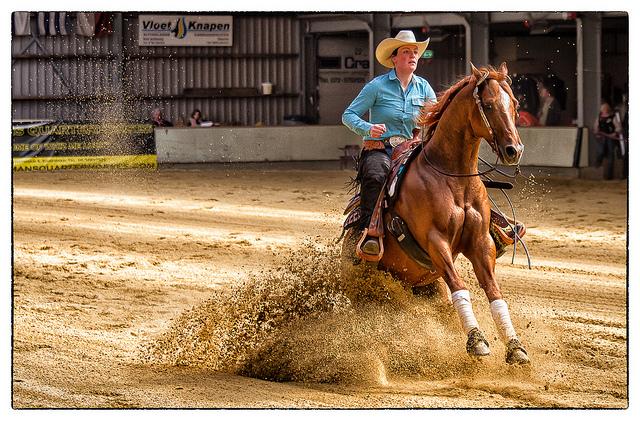Will the man hurt himself?
Quick response, please. No. Is the woman wearing a hat?
Concise answer only. Yes. What is the woman sitting on?
Short answer required. Horse. Is the horse hurt?
Give a very brief answer. No. 